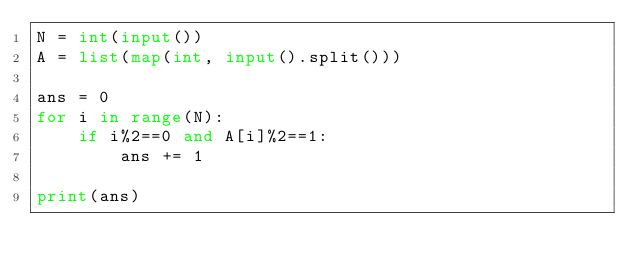Convert code to text. <code><loc_0><loc_0><loc_500><loc_500><_Python_>N = int(input())
A = list(map(int, input().split()))

ans = 0
for i in range(N):
    if i%2==0 and A[i]%2==1:
        ans += 1

print(ans)</code> 